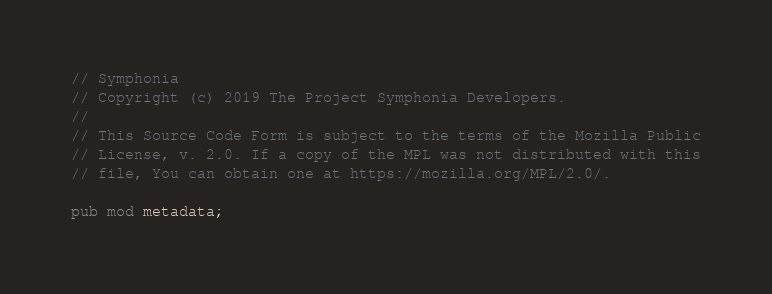<code> <loc_0><loc_0><loc_500><loc_500><_Rust_>// Symphonia
// Copyright (c) 2019 The Project Symphonia Developers.
//
// This Source Code Form is subject to the terms of the Mozilla Public
// License, v. 2.0. If a copy of the MPL was not distributed with this
// file, You can obtain one at https://mozilla.org/MPL/2.0/.

pub mod metadata;</code> 